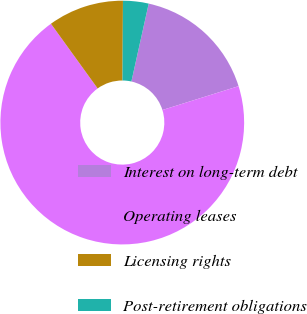Convert chart to OTSL. <chart><loc_0><loc_0><loc_500><loc_500><pie_chart><fcel>Interest on long-term debt<fcel>Operating leases<fcel>Licensing rights<fcel>Post-retirement obligations<nl><fcel>16.69%<fcel>69.88%<fcel>10.04%<fcel>3.39%<nl></chart> 